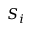Convert formula to latex. <formula><loc_0><loc_0><loc_500><loc_500>S _ { i }</formula> 